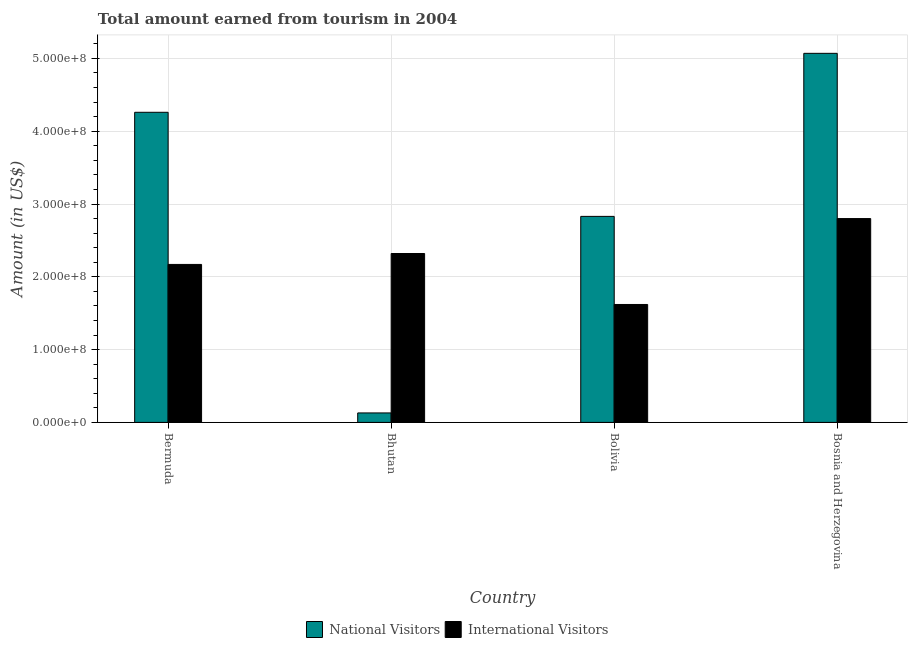How many different coloured bars are there?
Your answer should be compact. 2. Are the number of bars on each tick of the X-axis equal?
Provide a short and direct response. Yes. How many bars are there on the 2nd tick from the left?
Keep it short and to the point. 2. What is the label of the 4th group of bars from the left?
Your response must be concise. Bosnia and Herzegovina. In how many cases, is the number of bars for a given country not equal to the number of legend labels?
Give a very brief answer. 0. What is the amount earned from international visitors in Bolivia?
Your response must be concise. 1.62e+08. Across all countries, what is the maximum amount earned from national visitors?
Provide a short and direct response. 5.07e+08. Across all countries, what is the minimum amount earned from national visitors?
Offer a terse response. 1.30e+07. In which country was the amount earned from national visitors maximum?
Your answer should be very brief. Bosnia and Herzegovina. In which country was the amount earned from national visitors minimum?
Give a very brief answer. Bhutan. What is the total amount earned from international visitors in the graph?
Provide a succinct answer. 8.91e+08. What is the difference between the amount earned from international visitors in Bermuda and that in Bhutan?
Keep it short and to the point. -1.50e+07. What is the difference between the amount earned from international visitors in Bermuda and the amount earned from national visitors in Bhutan?
Provide a short and direct response. 2.04e+08. What is the average amount earned from international visitors per country?
Ensure brevity in your answer.  2.23e+08. What is the difference between the amount earned from international visitors and amount earned from national visitors in Bermuda?
Ensure brevity in your answer.  -2.09e+08. What is the ratio of the amount earned from international visitors in Bolivia to that in Bosnia and Herzegovina?
Provide a succinct answer. 0.58. What is the difference between the highest and the second highest amount earned from national visitors?
Give a very brief answer. 8.10e+07. What is the difference between the highest and the lowest amount earned from international visitors?
Offer a very short reply. 1.18e+08. In how many countries, is the amount earned from national visitors greater than the average amount earned from national visitors taken over all countries?
Give a very brief answer. 2. Is the sum of the amount earned from national visitors in Bhutan and Bosnia and Herzegovina greater than the maximum amount earned from international visitors across all countries?
Provide a short and direct response. Yes. What does the 2nd bar from the left in Bermuda represents?
Offer a very short reply. International Visitors. What does the 1st bar from the right in Bhutan represents?
Your answer should be compact. International Visitors. Are all the bars in the graph horizontal?
Your response must be concise. No. What is the difference between two consecutive major ticks on the Y-axis?
Provide a succinct answer. 1.00e+08. Does the graph contain any zero values?
Your response must be concise. No. Does the graph contain grids?
Give a very brief answer. Yes. How are the legend labels stacked?
Keep it short and to the point. Horizontal. What is the title of the graph?
Your response must be concise. Total amount earned from tourism in 2004. Does "Under-5(female)" appear as one of the legend labels in the graph?
Make the answer very short. No. What is the label or title of the Y-axis?
Ensure brevity in your answer.  Amount (in US$). What is the Amount (in US$) of National Visitors in Bermuda?
Your answer should be very brief. 4.26e+08. What is the Amount (in US$) of International Visitors in Bermuda?
Provide a succinct answer. 2.17e+08. What is the Amount (in US$) in National Visitors in Bhutan?
Your answer should be very brief. 1.30e+07. What is the Amount (in US$) of International Visitors in Bhutan?
Provide a succinct answer. 2.32e+08. What is the Amount (in US$) of National Visitors in Bolivia?
Keep it short and to the point. 2.83e+08. What is the Amount (in US$) of International Visitors in Bolivia?
Make the answer very short. 1.62e+08. What is the Amount (in US$) in National Visitors in Bosnia and Herzegovina?
Make the answer very short. 5.07e+08. What is the Amount (in US$) of International Visitors in Bosnia and Herzegovina?
Your answer should be compact. 2.80e+08. Across all countries, what is the maximum Amount (in US$) of National Visitors?
Your answer should be compact. 5.07e+08. Across all countries, what is the maximum Amount (in US$) of International Visitors?
Provide a short and direct response. 2.80e+08. Across all countries, what is the minimum Amount (in US$) in National Visitors?
Your response must be concise. 1.30e+07. Across all countries, what is the minimum Amount (in US$) in International Visitors?
Offer a terse response. 1.62e+08. What is the total Amount (in US$) of National Visitors in the graph?
Offer a terse response. 1.23e+09. What is the total Amount (in US$) of International Visitors in the graph?
Provide a succinct answer. 8.91e+08. What is the difference between the Amount (in US$) in National Visitors in Bermuda and that in Bhutan?
Offer a very short reply. 4.13e+08. What is the difference between the Amount (in US$) of International Visitors in Bermuda and that in Bhutan?
Provide a succinct answer. -1.50e+07. What is the difference between the Amount (in US$) in National Visitors in Bermuda and that in Bolivia?
Make the answer very short. 1.43e+08. What is the difference between the Amount (in US$) in International Visitors in Bermuda and that in Bolivia?
Your answer should be compact. 5.50e+07. What is the difference between the Amount (in US$) in National Visitors in Bermuda and that in Bosnia and Herzegovina?
Give a very brief answer. -8.10e+07. What is the difference between the Amount (in US$) of International Visitors in Bermuda and that in Bosnia and Herzegovina?
Offer a very short reply. -6.30e+07. What is the difference between the Amount (in US$) in National Visitors in Bhutan and that in Bolivia?
Make the answer very short. -2.70e+08. What is the difference between the Amount (in US$) in International Visitors in Bhutan and that in Bolivia?
Give a very brief answer. 7.00e+07. What is the difference between the Amount (in US$) in National Visitors in Bhutan and that in Bosnia and Herzegovina?
Provide a succinct answer. -4.94e+08. What is the difference between the Amount (in US$) of International Visitors in Bhutan and that in Bosnia and Herzegovina?
Offer a very short reply. -4.80e+07. What is the difference between the Amount (in US$) in National Visitors in Bolivia and that in Bosnia and Herzegovina?
Keep it short and to the point. -2.24e+08. What is the difference between the Amount (in US$) in International Visitors in Bolivia and that in Bosnia and Herzegovina?
Your response must be concise. -1.18e+08. What is the difference between the Amount (in US$) in National Visitors in Bermuda and the Amount (in US$) in International Visitors in Bhutan?
Your answer should be compact. 1.94e+08. What is the difference between the Amount (in US$) of National Visitors in Bermuda and the Amount (in US$) of International Visitors in Bolivia?
Offer a terse response. 2.64e+08. What is the difference between the Amount (in US$) in National Visitors in Bermuda and the Amount (in US$) in International Visitors in Bosnia and Herzegovina?
Give a very brief answer. 1.46e+08. What is the difference between the Amount (in US$) in National Visitors in Bhutan and the Amount (in US$) in International Visitors in Bolivia?
Make the answer very short. -1.49e+08. What is the difference between the Amount (in US$) in National Visitors in Bhutan and the Amount (in US$) in International Visitors in Bosnia and Herzegovina?
Your response must be concise. -2.67e+08. What is the average Amount (in US$) in National Visitors per country?
Your response must be concise. 3.07e+08. What is the average Amount (in US$) of International Visitors per country?
Provide a succinct answer. 2.23e+08. What is the difference between the Amount (in US$) in National Visitors and Amount (in US$) in International Visitors in Bermuda?
Offer a very short reply. 2.09e+08. What is the difference between the Amount (in US$) in National Visitors and Amount (in US$) in International Visitors in Bhutan?
Keep it short and to the point. -2.19e+08. What is the difference between the Amount (in US$) in National Visitors and Amount (in US$) in International Visitors in Bolivia?
Provide a short and direct response. 1.21e+08. What is the difference between the Amount (in US$) of National Visitors and Amount (in US$) of International Visitors in Bosnia and Herzegovina?
Keep it short and to the point. 2.27e+08. What is the ratio of the Amount (in US$) in National Visitors in Bermuda to that in Bhutan?
Keep it short and to the point. 32.77. What is the ratio of the Amount (in US$) of International Visitors in Bermuda to that in Bhutan?
Give a very brief answer. 0.94. What is the ratio of the Amount (in US$) of National Visitors in Bermuda to that in Bolivia?
Provide a succinct answer. 1.51. What is the ratio of the Amount (in US$) of International Visitors in Bermuda to that in Bolivia?
Provide a succinct answer. 1.34. What is the ratio of the Amount (in US$) of National Visitors in Bermuda to that in Bosnia and Herzegovina?
Offer a terse response. 0.84. What is the ratio of the Amount (in US$) of International Visitors in Bermuda to that in Bosnia and Herzegovina?
Offer a very short reply. 0.78. What is the ratio of the Amount (in US$) of National Visitors in Bhutan to that in Bolivia?
Give a very brief answer. 0.05. What is the ratio of the Amount (in US$) of International Visitors in Bhutan to that in Bolivia?
Give a very brief answer. 1.43. What is the ratio of the Amount (in US$) of National Visitors in Bhutan to that in Bosnia and Herzegovina?
Your response must be concise. 0.03. What is the ratio of the Amount (in US$) in International Visitors in Bhutan to that in Bosnia and Herzegovina?
Offer a very short reply. 0.83. What is the ratio of the Amount (in US$) in National Visitors in Bolivia to that in Bosnia and Herzegovina?
Provide a short and direct response. 0.56. What is the ratio of the Amount (in US$) in International Visitors in Bolivia to that in Bosnia and Herzegovina?
Give a very brief answer. 0.58. What is the difference between the highest and the second highest Amount (in US$) in National Visitors?
Keep it short and to the point. 8.10e+07. What is the difference between the highest and the second highest Amount (in US$) in International Visitors?
Keep it short and to the point. 4.80e+07. What is the difference between the highest and the lowest Amount (in US$) of National Visitors?
Provide a succinct answer. 4.94e+08. What is the difference between the highest and the lowest Amount (in US$) in International Visitors?
Provide a short and direct response. 1.18e+08. 